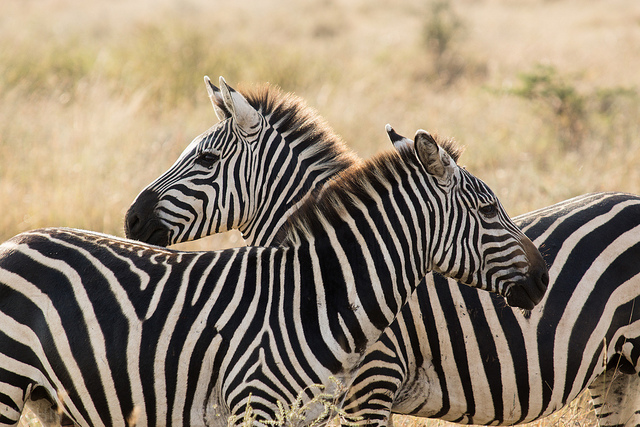What time of day do you think it is in this picture? It appears to be either early morning or late afternoon, as the lighting suggests a soft, angled light typical of sunrise or sunset. What can you infer about the zebras' behavior from their positioning? The way the zebras are positioned, standing close together and facing different directions, suggests they might be on alert for predators while still maintaining social interaction with each other. This behavior is common among prey animals to ensure greater vigilance against threats. Describe a realistic scenario involving these zebras. In a serene savannah during the early hours of the morning, these two zebras are taking a brief respite from grazing. With the sun gently rising, casting a golden glow, they remain alert to their surroundings, facing different directions to better watch for any approaching predators. Their unity and cautious nature highlight the ever-present balance between survival and social interaction in the wild. If these zebras were part of a bigger herd, what other animals might they encounter in their habitat? In their natural habitat, zebras might encounter a variety of other animals such as wildebeest, gazelles, antelopes, and sometimes giraffes. Predators like lions, hyenas, and cheetahs are also common in the areas zebras inhabit, making vigilance crucial for their survival. 